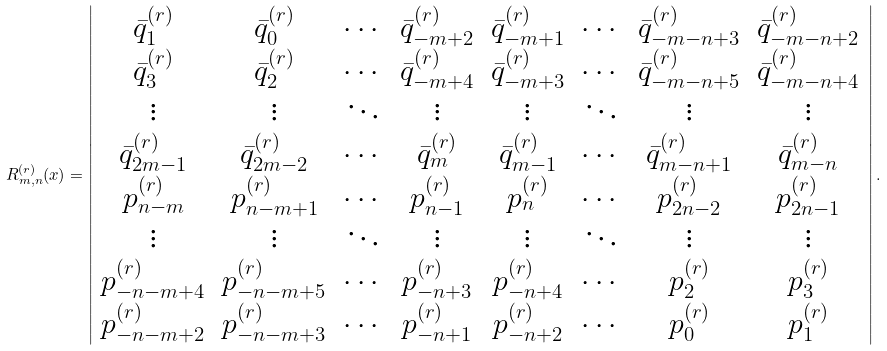<formula> <loc_0><loc_0><loc_500><loc_500>R _ { m , n } ^ { ( r ) } ( x ) = \left | \begin{array} { c c c c c c c c } \bar { q } _ { 1 } ^ { ( r ) } & \bar { q } _ { 0 } ^ { ( r ) } & \cdots & \bar { q } _ { - m + 2 } ^ { ( r ) } & \bar { q } _ { - m + 1 } ^ { ( r ) } & \cdots & \bar { q } _ { - m - n + 3 } ^ { ( r ) } & \bar { q } _ { - m - n + 2 } ^ { ( r ) } \\ \bar { q } _ { 3 } ^ { ( r ) } & \bar { q } _ { 2 } ^ { ( r ) } & \cdots & \bar { q } _ { - m + 4 } ^ { ( r ) } & \bar { q } _ { - m + 3 } ^ { ( r ) } & \cdots & \bar { q } _ { - m - n + 5 } ^ { ( r ) } & \bar { q } _ { - m - n + 4 } ^ { ( r ) } \\ \vdots & \vdots & \ddots & \vdots & \vdots & \ddots & \vdots & \vdots \\ \bar { q } _ { 2 m - 1 } ^ { ( r ) } & \bar { q } _ { 2 m - 2 } ^ { ( r ) } & \cdots & \bar { q } _ { m } ^ { ( r ) } & \bar { q } _ { m - 1 } ^ { ( r ) } & \cdots & \bar { q } _ { m - n + 1 } ^ { ( r ) } & \bar { q } _ { m - n } ^ { ( r ) } \\ p _ { n - m } ^ { ( r ) } & p _ { n - m + 1 } ^ { ( r ) } & \cdots & p _ { n - 1 } ^ { ( r ) } & p _ { n } ^ { ( r ) } & \cdots & p _ { 2 n - 2 } ^ { ( r ) } & p _ { 2 n - 1 } ^ { ( r ) } \\ \vdots & \vdots & \ddots & \vdots & \vdots & \ddots & \vdots & \vdots \\ p _ { - n - m + 4 } ^ { ( r ) } & p _ { - n - m + 5 } ^ { ( r ) } & \cdots & p _ { - n + 3 } ^ { ( r ) } & p _ { - n + 4 } ^ { ( r ) } & \cdots & p _ { 2 } ^ { ( r ) } & p _ { 3 } ^ { ( r ) } \\ p _ { - n - m + 2 } ^ { ( r ) } & p _ { - n - m + 3 } ^ { ( r ) } & \cdots & p _ { - n + 1 } ^ { ( r ) } & p _ { - n + 2 } ^ { ( r ) } & \cdots & p _ { 0 } ^ { ( r ) } & p _ { 1 } ^ { ( r ) } \end{array} \right | .</formula> 